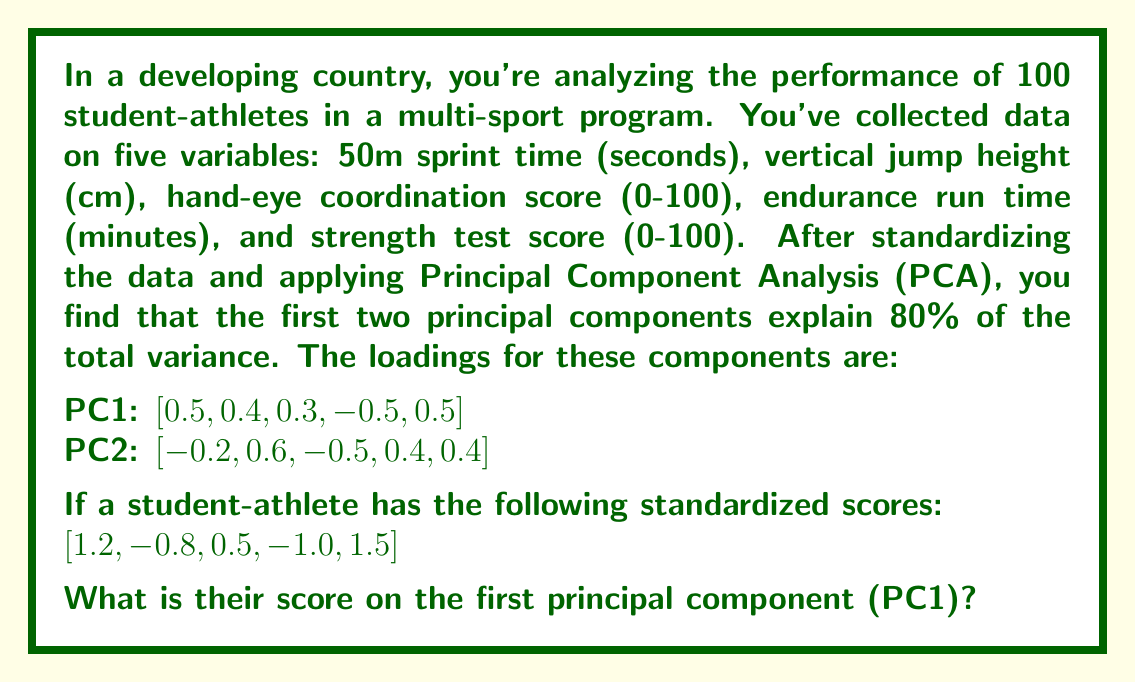Teach me how to tackle this problem. To solve this problem, we need to understand and apply the concept of Principal Component Analysis (PCA) and how to calculate component scores.

1. Understanding PCA:
   PCA is a dimensionality reduction technique that transforms a set of correlated variables into a smaller set of uncorrelated variables called principal components.

2. Component Loadings:
   The loadings represent the weight of each original variable in the principal component. They indicate how much each variable contributes to the component.

3. Calculating Component Scores:
   To calculate a score on a principal component, we multiply each standardized variable value by its corresponding loading and sum the results.

4. Given Information:
   - PC1 loadings: [0.5, 0.4, 0.3, -0.5, 0.5]
   - Student-athlete's standardized scores: [1.2, -0.8, 0.5, -1.0, 1.5]

5. Calculation:
   Let's multiply each standardized score by its corresponding loading and sum the results:

   $$\begin{align}
   \text{PC1 Score} &= (1.2 \times 0.5) + (-0.8 \times 0.4) + (0.5 \times 0.3) + (-1.0 \times -0.5) + (1.5 \times 0.5) \\
   &= 0.6 + (-0.32) + 0.15 + 0.5 + 0.75 \\
   &= 1.68
   \end{align}$$

Therefore, the student-athlete's score on the first principal component (PC1) is 1.68.
Answer: 1.68 